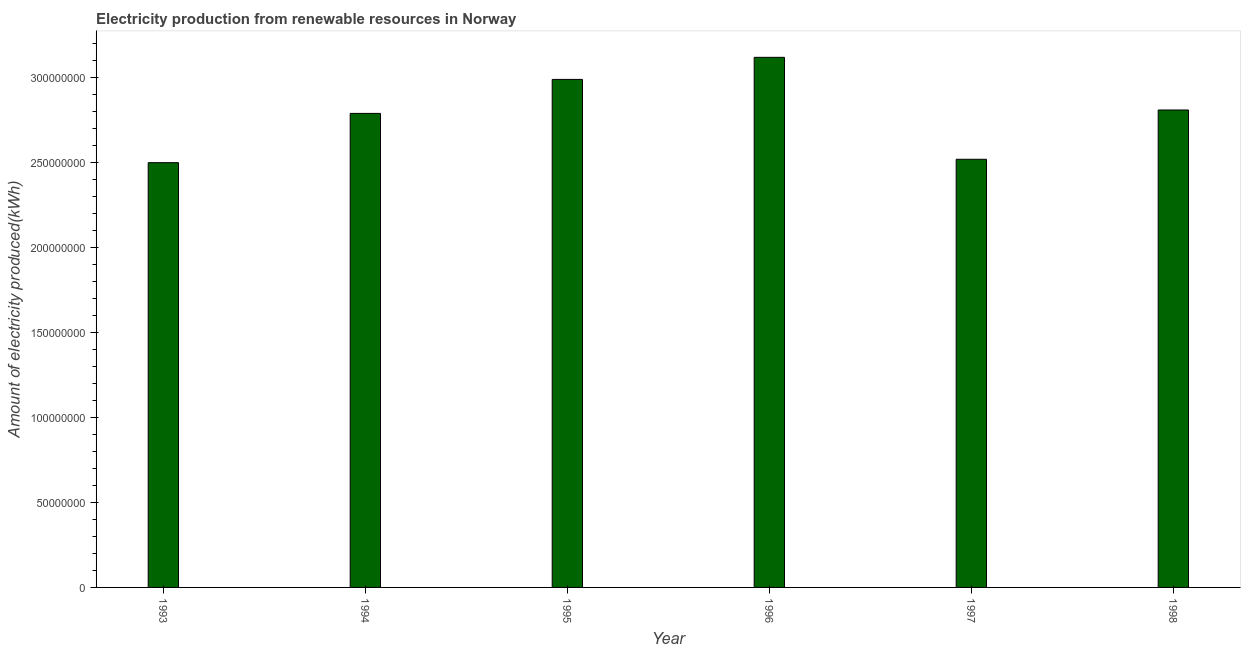Does the graph contain any zero values?
Provide a short and direct response. No. Does the graph contain grids?
Your response must be concise. No. What is the title of the graph?
Make the answer very short. Electricity production from renewable resources in Norway. What is the label or title of the X-axis?
Offer a terse response. Year. What is the label or title of the Y-axis?
Your answer should be very brief. Amount of electricity produced(kWh). What is the amount of electricity produced in 1998?
Provide a short and direct response. 2.81e+08. Across all years, what is the maximum amount of electricity produced?
Provide a succinct answer. 3.12e+08. Across all years, what is the minimum amount of electricity produced?
Give a very brief answer. 2.50e+08. In which year was the amount of electricity produced minimum?
Ensure brevity in your answer.  1993. What is the sum of the amount of electricity produced?
Keep it short and to the point. 1.67e+09. What is the difference between the amount of electricity produced in 1994 and 1997?
Give a very brief answer. 2.70e+07. What is the average amount of electricity produced per year?
Make the answer very short. 2.79e+08. What is the median amount of electricity produced?
Offer a very short reply. 2.80e+08. In how many years, is the amount of electricity produced greater than 80000000 kWh?
Your response must be concise. 6. What is the ratio of the amount of electricity produced in 1997 to that in 1998?
Offer a very short reply. 0.9. What is the difference between the highest and the second highest amount of electricity produced?
Ensure brevity in your answer.  1.30e+07. Is the sum of the amount of electricity produced in 1993 and 1997 greater than the maximum amount of electricity produced across all years?
Your answer should be very brief. Yes. What is the difference between the highest and the lowest amount of electricity produced?
Ensure brevity in your answer.  6.20e+07. Are all the bars in the graph horizontal?
Make the answer very short. No. What is the difference between two consecutive major ticks on the Y-axis?
Provide a short and direct response. 5.00e+07. Are the values on the major ticks of Y-axis written in scientific E-notation?
Ensure brevity in your answer.  No. What is the Amount of electricity produced(kWh) in 1993?
Give a very brief answer. 2.50e+08. What is the Amount of electricity produced(kWh) of 1994?
Ensure brevity in your answer.  2.79e+08. What is the Amount of electricity produced(kWh) in 1995?
Ensure brevity in your answer.  2.99e+08. What is the Amount of electricity produced(kWh) in 1996?
Your answer should be very brief. 3.12e+08. What is the Amount of electricity produced(kWh) in 1997?
Offer a terse response. 2.52e+08. What is the Amount of electricity produced(kWh) of 1998?
Your response must be concise. 2.81e+08. What is the difference between the Amount of electricity produced(kWh) in 1993 and 1994?
Your answer should be very brief. -2.90e+07. What is the difference between the Amount of electricity produced(kWh) in 1993 and 1995?
Provide a short and direct response. -4.90e+07. What is the difference between the Amount of electricity produced(kWh) in 1993 and 1996?
Provide a short and direct response. -6.20e+07. What is the difference between the Amount of electricity produced(kWh) in 1993 and 1998?
Give a very brief answer. -3.10e+07. What is the difference between the Amount of electricity produced(kWh) in 1994 and 1995?
Provide a short and direct response. -2.00e+07. What is the difference between the Amount of electricity produced(kWh) in 1994 and 1996?
Make the answer very short. -3.30e+07. What is the difference between the Amount of electricity produced(kWh) in 1994 and 1997?
Offer a terse response. 2.70e+07. What is the difference between the Amount of electricity produced(kWh) in 1994 and 1998?
Provide a succinct answer. -2.00e+06. What is the difference between the Amount of electricity produced(kWh) in 1995 and 1996?
Make the answer very short. -1.30e+07. What is the difference between the Amount of electricity produced(kWh) in 1995 and 1997?
Keep it short and to the point. 4.70e+07. What is the difference between the Amount of electricity produced(kWh) in 1995 and 1998?
Your response must be concise. 1.80e+07. What is the difference between the Amount of electricity produced(kWh) in 1996 and 1997?
Provide a succinct answer. 6.00e+07. What is the difference between the Amount of electricity produced(kWh) in 1996 and 1998?
Your answer should be compact. 3.10e+07. What is the difference between the Amount of electricity produced(kWh) in 1997 and 1998?
Your answer should be very brief. -2.90e+07. What is the ratio of the Amount of electricity produced(kWh) in 1993 to that in 1994?
Provide a short and direct response. 0.9. What is the ratio of the Amount of electricity produced(kWh) in 1993 to that in 1995?
Give a very brief answer. 0.84. What is the ratio of the Amount of electricity produced(kWh) in 1993 to that in 1996?
Make the answer very short. 0.8. What is the ratio of the Amount of electricity produced(kWh) in 1993 to that in 1998?
Provide a short and direct response. 0.89. What is the ratio of the Amount of electricity produced(kWh) in 1994 to that in 1995?
Your response must be concise. 0.93. What is the ratio of the Amount of electricity produced(kWh) in 1994 to that in 1996?
Provide a succinct answer. 0.89. What is the ratio of the Amount of electricity produced(kWh) in 1994 to that in 1997?
Your answer should be compact. 1.11. What is the ratio of the Amount of electricity produced(kWh) in 1994 to that in 1998?
Offer a terse response. 0.99. What is the ratio of the Amount of electricity produced(kWh) in 1995 to that in 1996?
Your response must be concise. 0.96. What is the ratio of the Amount of electricity produced(kWh) in 1995 to that in 1997?
Provide a succinct answer. 1.19. What is the ratio of the Amount of electricity produced(kWh) in 1995 to that in 1998?
Ensure brevity in your answer.  1.06. What is the ratio of the Amount of electricity produced(kWh) in 1996 to that in 1997?
Your answer should be very brief. 1.24. What is the ratio of the Amount of electricity produced(kWh) in 1996 to that in 1998?
Your answer should be very brief. 1.11. What is the ratio of the Amount of electricity produced(kWh) in 1997 to that in 1998?
Give a very brief answer. 0.9. 